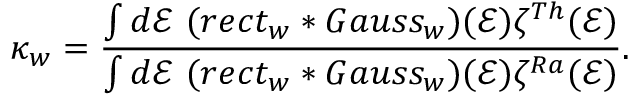<formula> <loc_0><loc_0><loc_500><loc_500>\kappa _ { w } = \frac { \int d \mathcal { E } ( r e c t _ { w } \ast G a u s s _ { w } ) ( \mathcal { E } ) \zeta ^ { T h } ( \mathcal { E } ) } { \int d \mathcal { E } ( r e c t _ { w } \ast G a u s s _ { w } ) ( \mathcal { E } ) \zeta ^ { R a } ( \mathcal { E } ) } .</formula> 